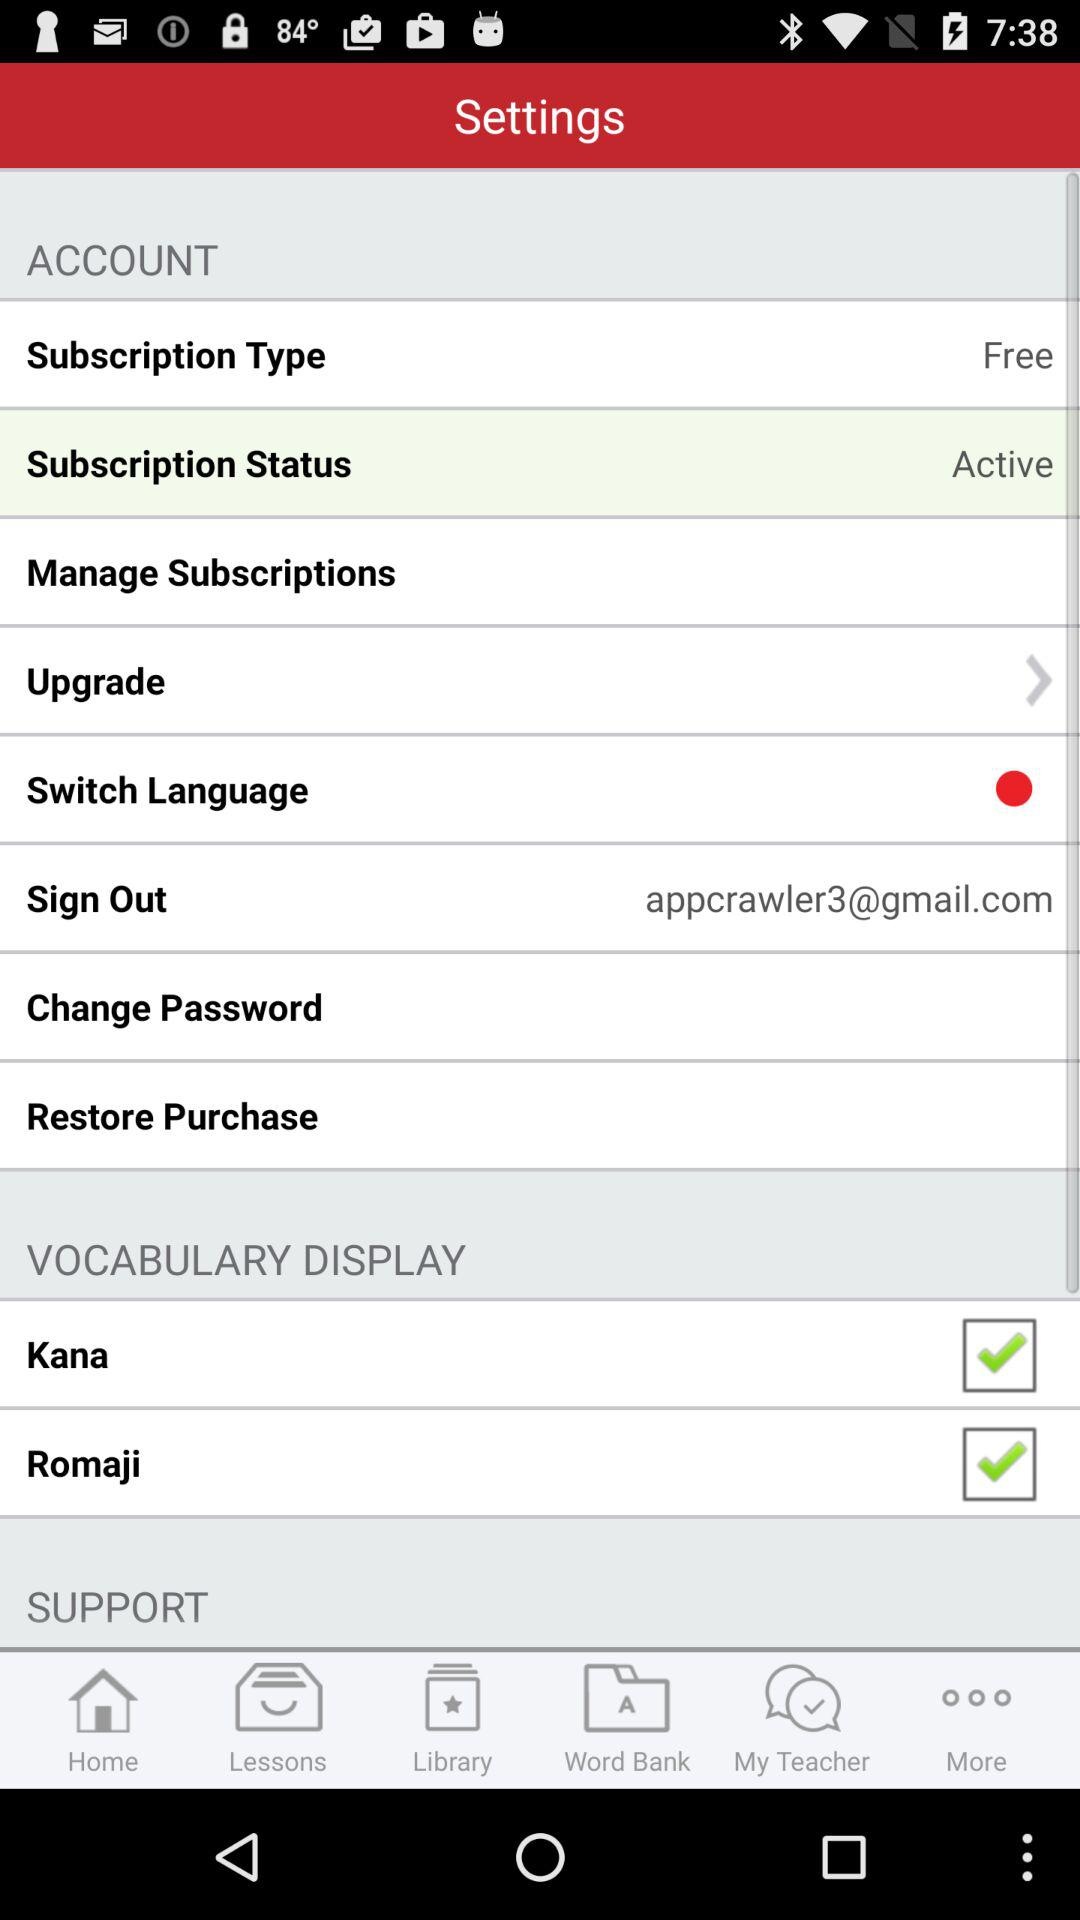What is the status of "Kana"? The status of "Kana" is "on". 